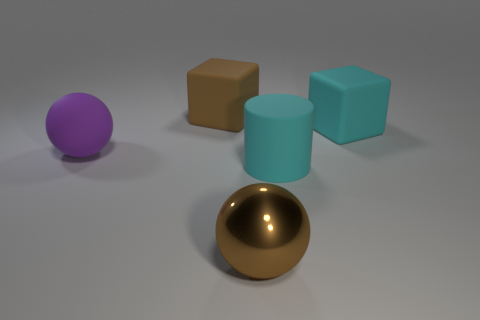Is there a metal sphere of the same size as the brown shiny object?
Offer a terse response. No. There is another big thing that is the same shape as the large shiny object; what is its material?
Provide a short and direct response. Rubber. What shape is the cyan object that is the same size as the cyan matte cube?
Your response must be concise. Cylinder. Is there another thing of the same shape as the metal object?
Make the answer very short. Yes. What shape is the object in front of the cyan rubber object that is in front of the cyan cube?
Provide a succinct answer. Sphere. What shape is the brown rubber thing?
Keep it short and to the point. Cube. What material is the large brown object that is in front of the large cyan object right of the large cyan object in front of the large matte sphere?
Ensure brevity in your answer.  Metal. How many other things are there of the same material as the large brown sphere?
Ensure brevity in your answer.  0. How many brown cubes are behind the big brown object behind the large brown shiny sphere?
Give a very brief answer. 0. What number of cylinders are either purple objects or rubber things?
Your answer should be compact. 1. 